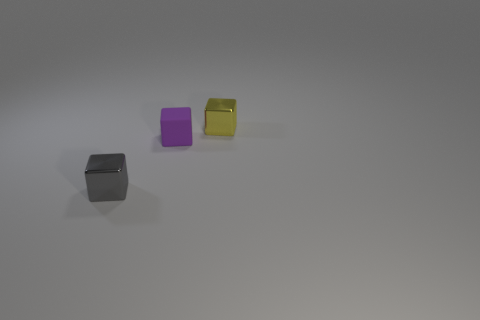Subtract all metal blocks. How many blocks are left? 1 Add 3 big red rubber cylinders. How many objects exist? 6 Subtract 2 cubes. How many cubes are left? 1 Add 3 yellow blocks. How many yellow blocks exist? 4 Subtract all yellow blocks. How many blocks are left? 2 Subtract 0 gray spheres. How many objects are left? 3 Subtract all red cubes. Subtract all green cylinders. How many cubes are left? 3 Subtract all gray blocks. Subtract all matte blocks. How many objects are left? 1 Add 3 yellow metallic objects. How many yellow metallic objects are left? 4 